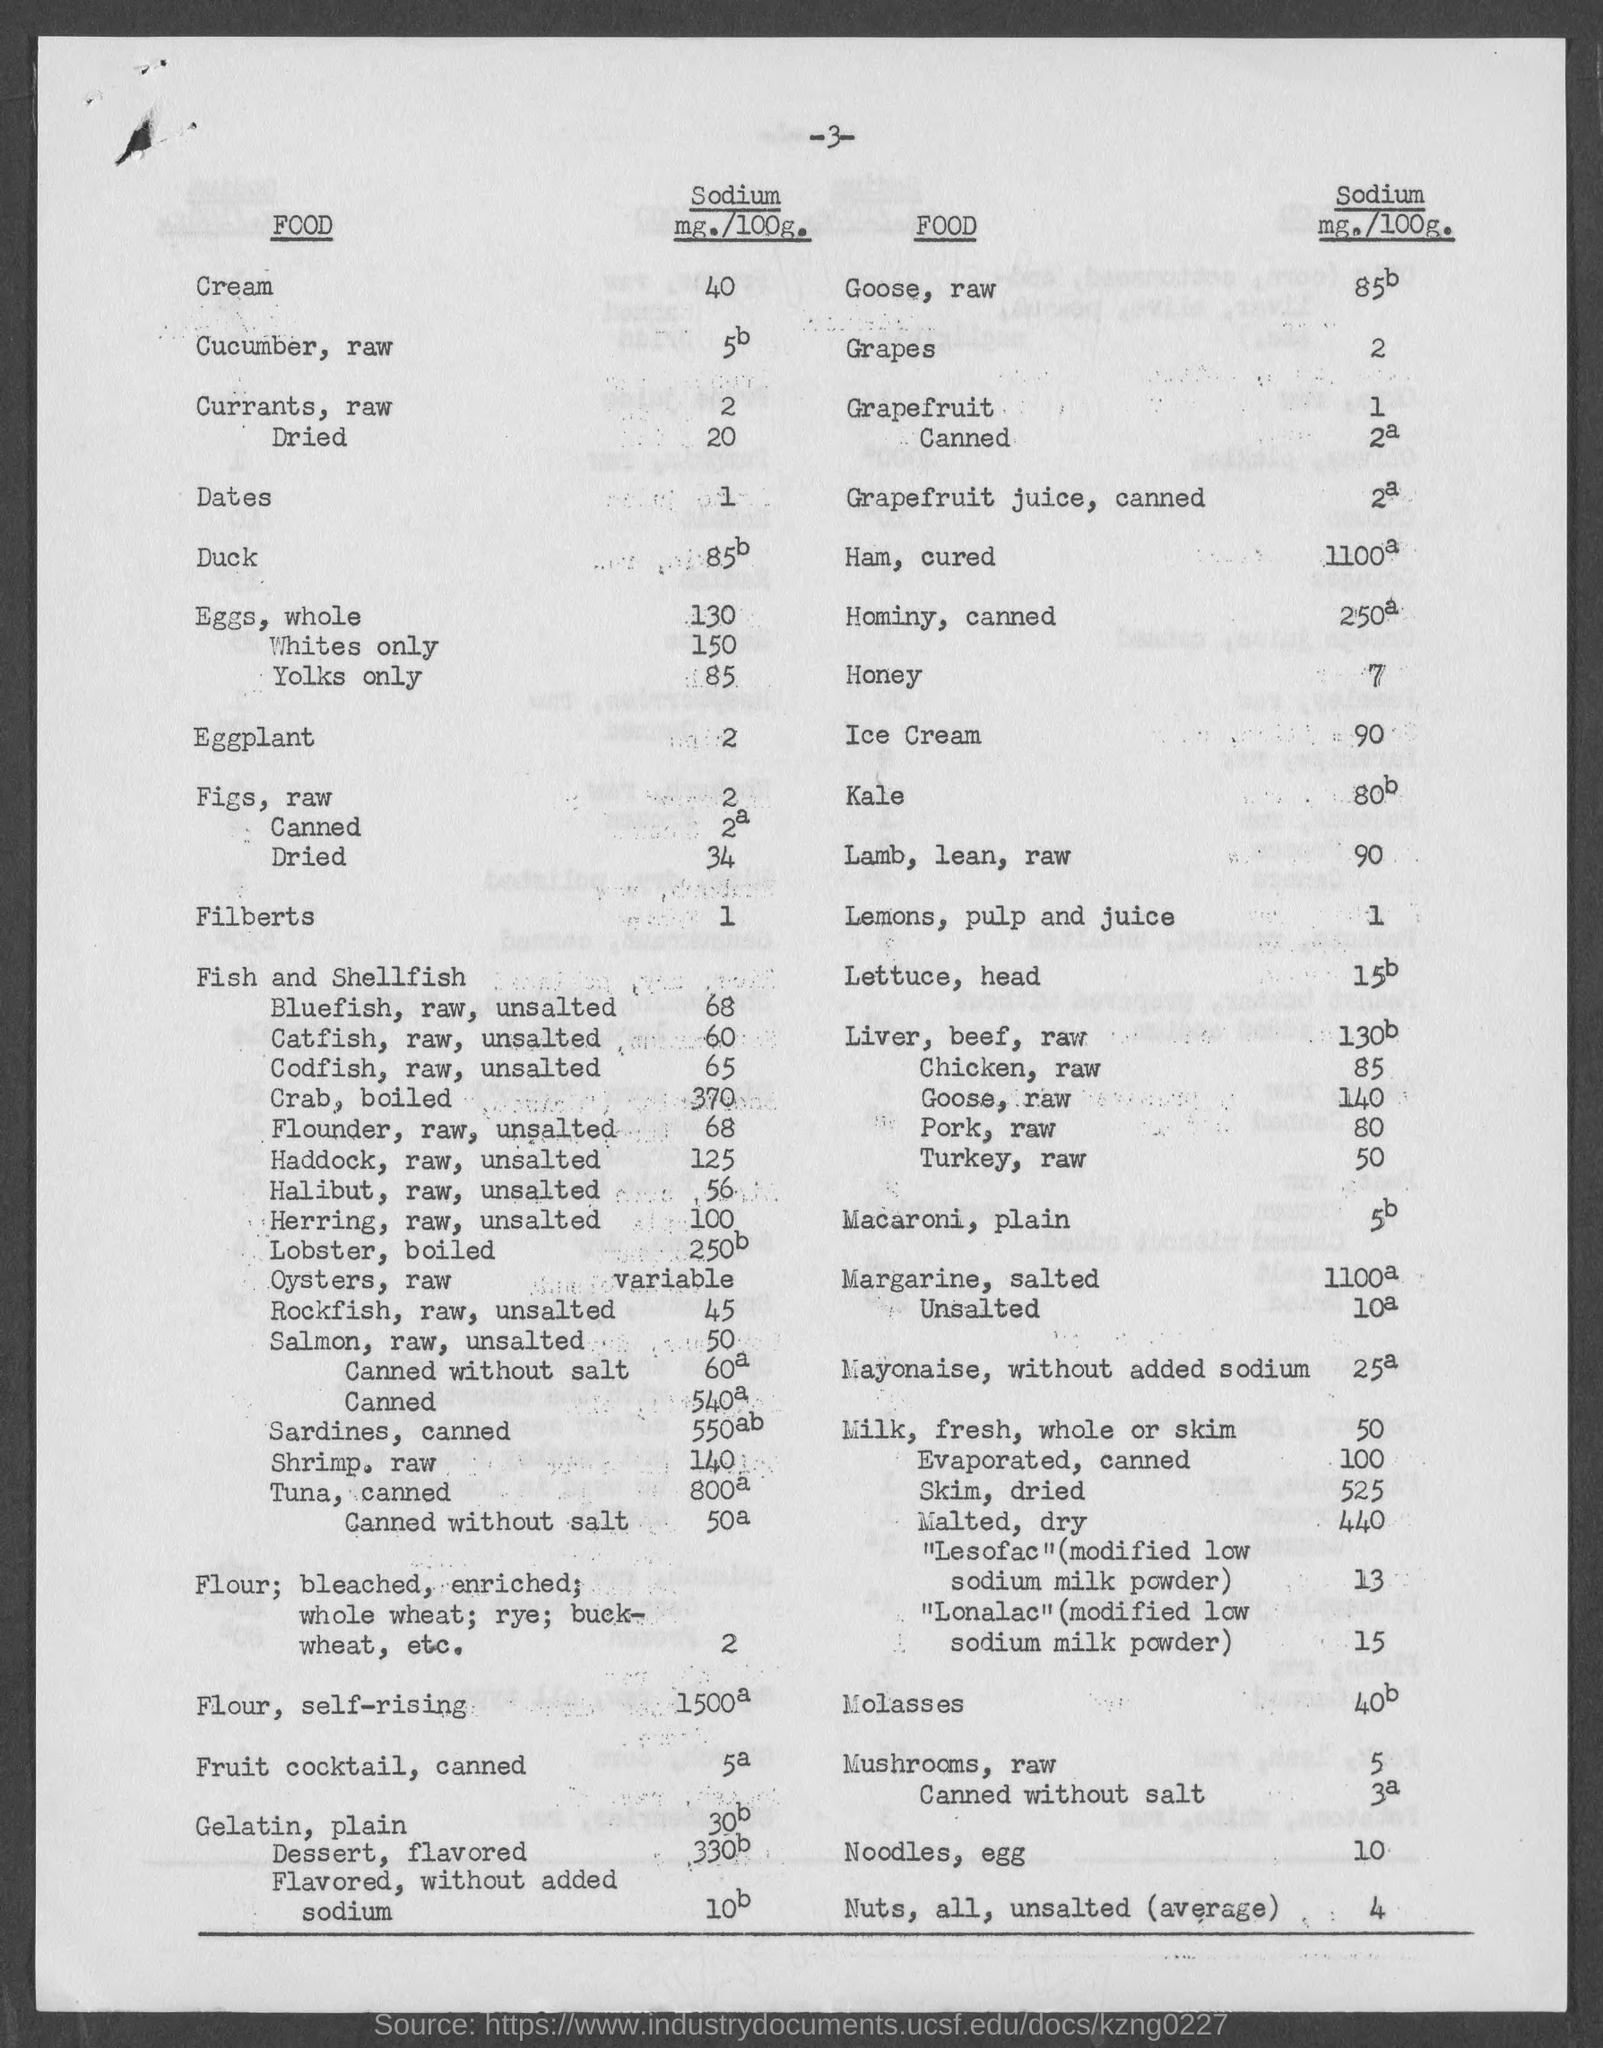Point out several critical features in this image. The page number mentioned in this document is -3-. The amount of sodium in grapes is approximately 2 milligrams per 100 grams. The amount of sodium in eggplant is 2 milligrams per 100 grams. The amount of sodium present in dates is 1. The amount of sodium present in honey is approximately 7 milligrams per 100 grams. 